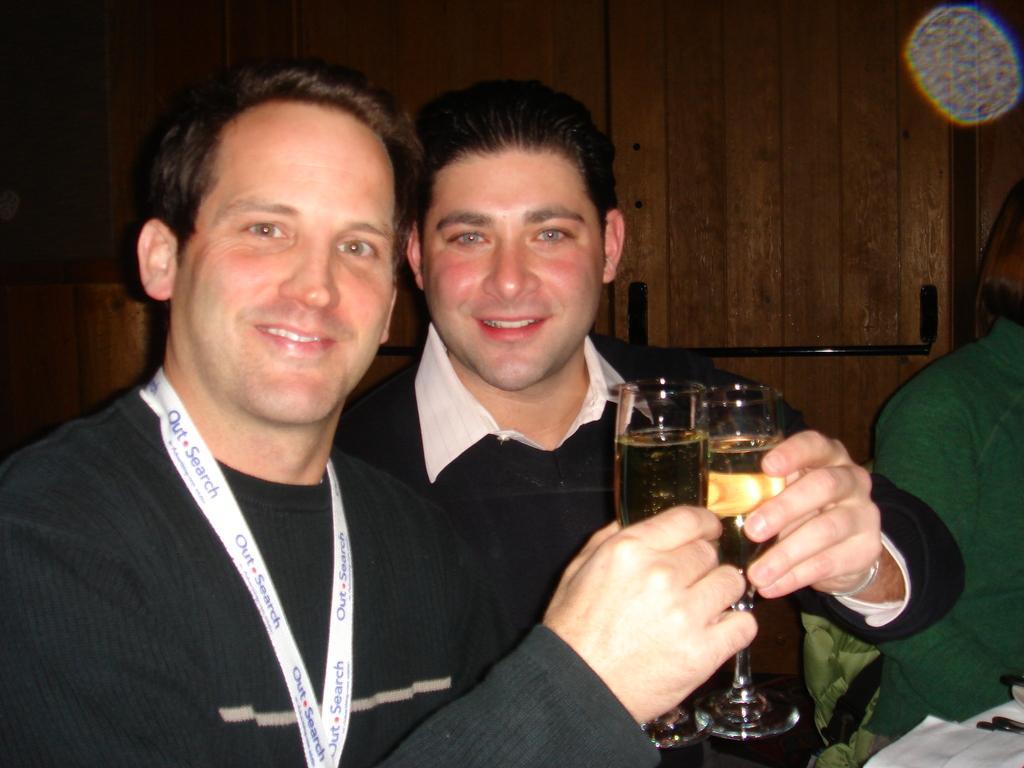Could you give a brief overview of what you see in this image? In this image we can see two persons are holding a glass with drink in their hands. In the background of the image we can see a wooden wall. 